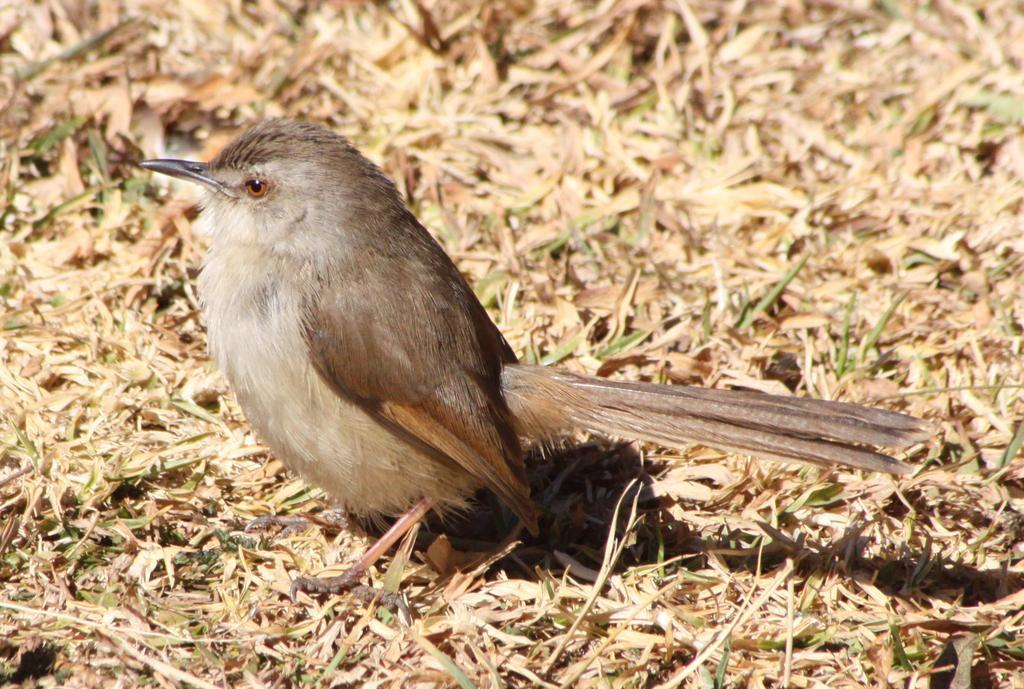What type of animal can be seen in the image? There is a bird in the image. Where is the bird located? The bird is on the ground. What can be seen in the background of the image? There are dried leaves in the background of the image. What is the bird's weight on the scale in the image? There is no scale present in the image, so it is not possible to determine the bird's weight. 